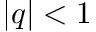Convert formula to latex. <formula><loc_0><loc_0><loc_500><loc_500>| q | < 1</formula> 